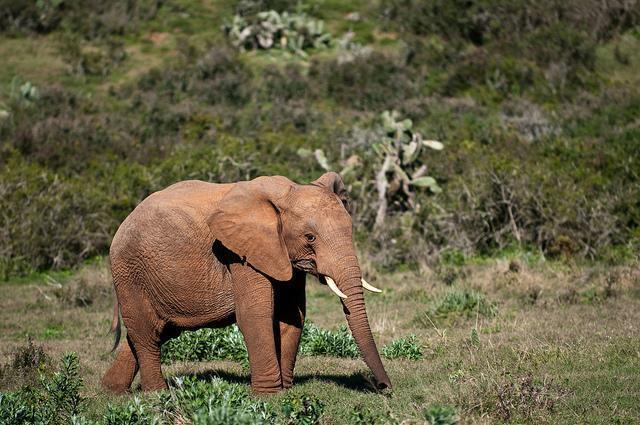How many elephants are there?
Give a very brief answer. 1. How many zebras have all of their feet in the grass?
Give a very brief answer. 0. 